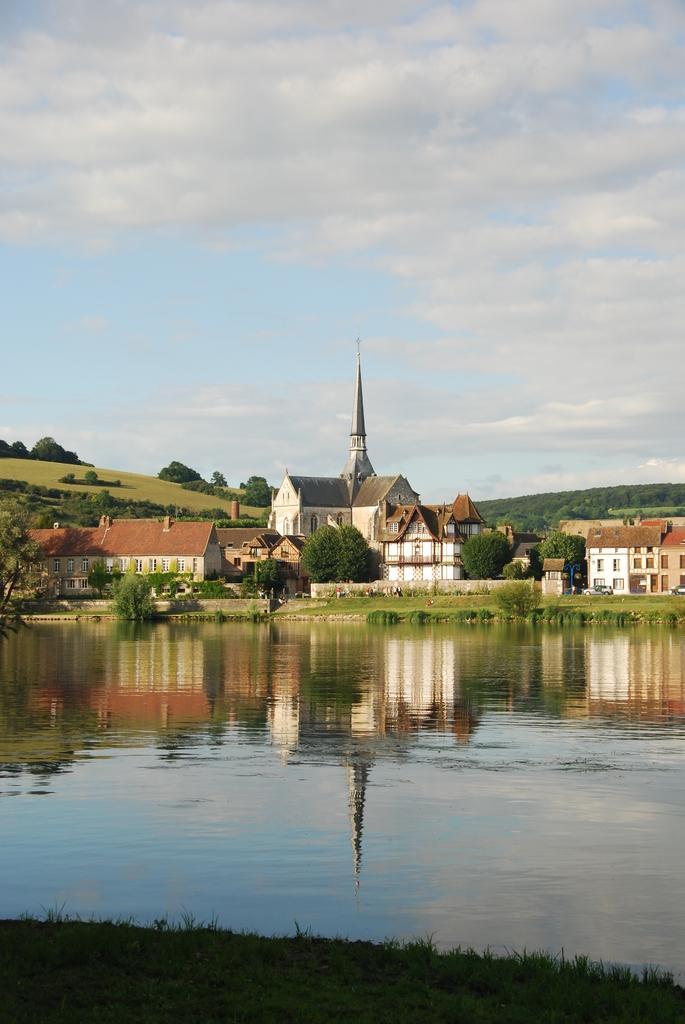Describe this image in one or two sentences. In this picture I can see water, there are buildings, there are trees, hills, and in the background there is the sky. 